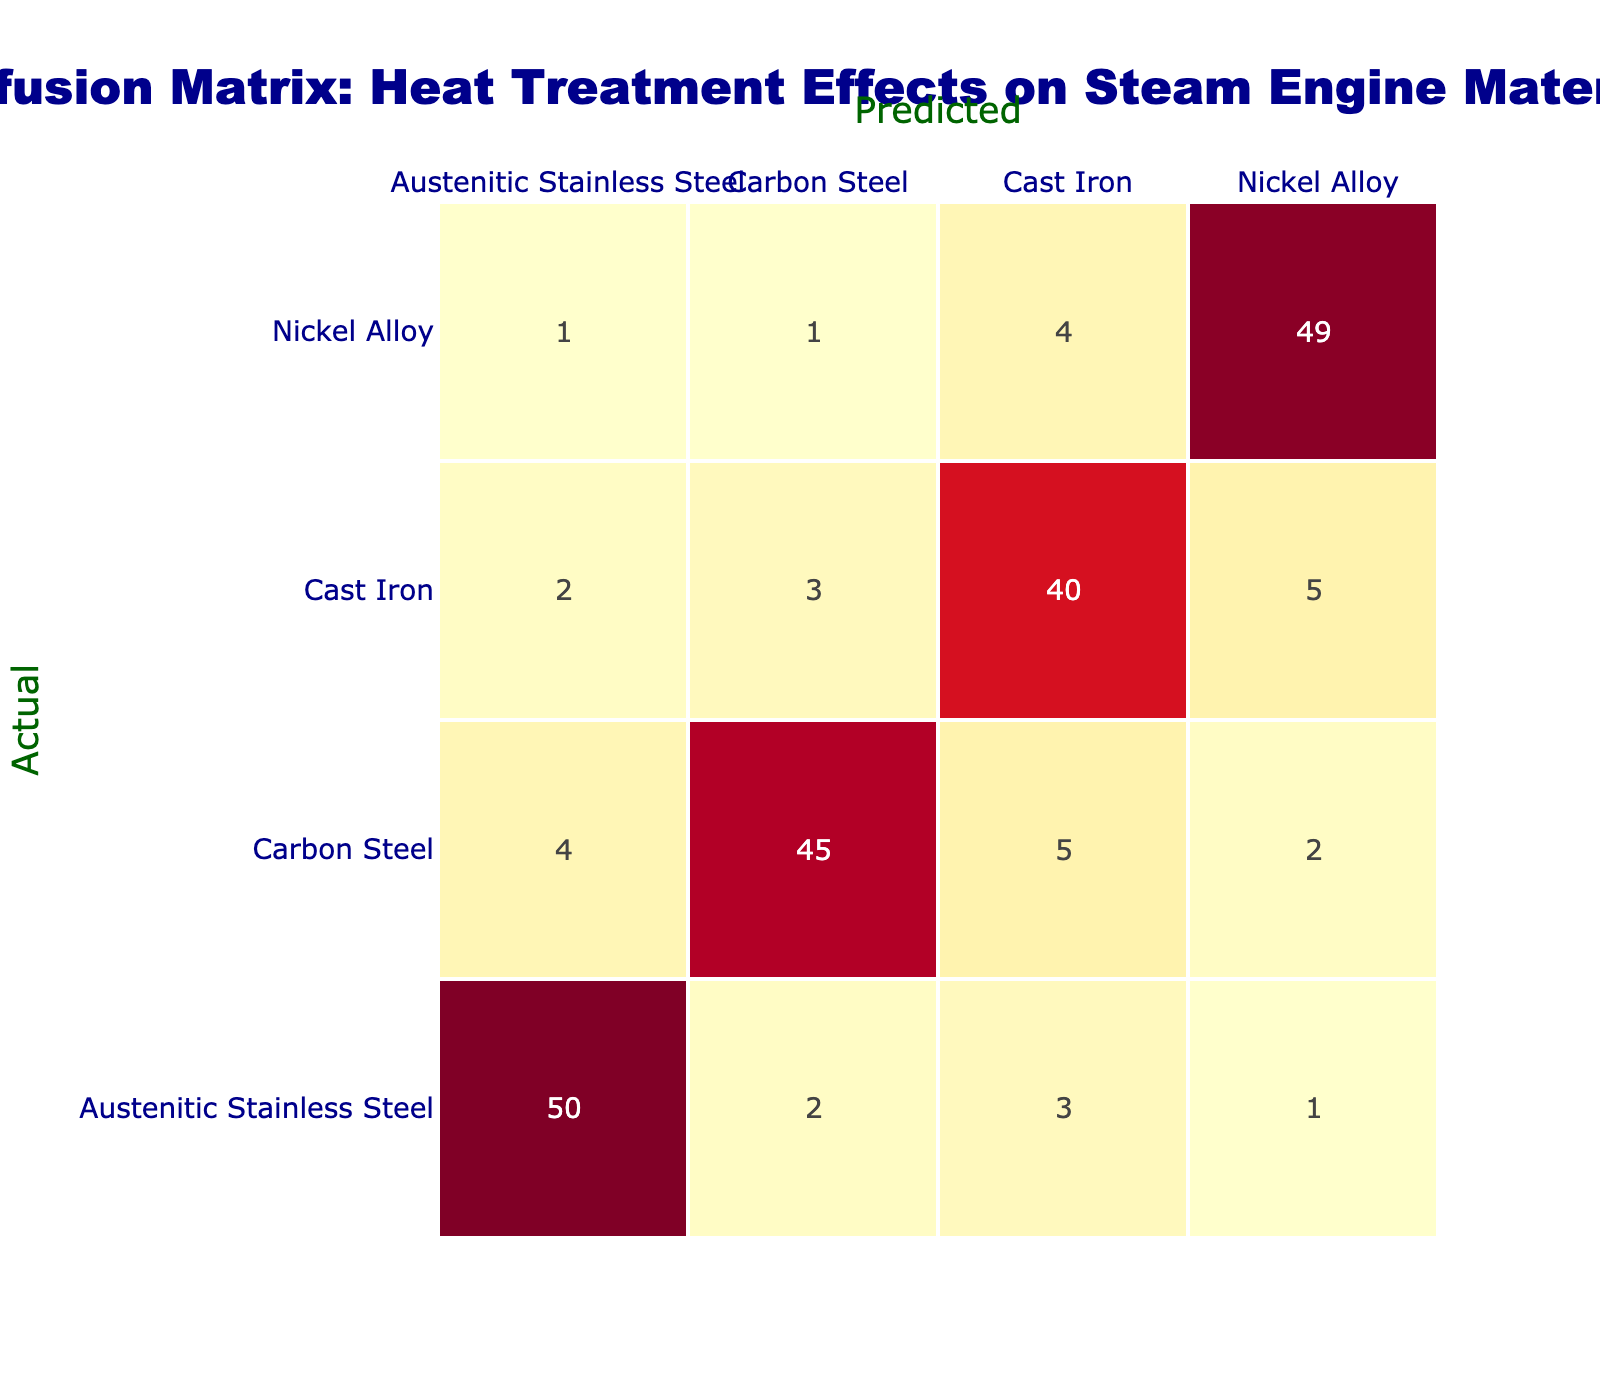What is the predicted number of Austenitic Stainless Steel components? In the table, the row for predicted Austenitic Stainless Steel shows '50', which is the value in that cell.
Answer: 50 What is the total number of errors in predicting Carbon Steel? To find the total errors for Carbon Steel, add the numbers in the Carbon Steel row that are not on the diagonal: 4 (Austenitic Stainless Steel) + 5 (Cast Iron) + 2 (Nickel Alloy) = 11.
Answer: 11 Is it true that more Nickel Alloy components were misclassified as Cast Iron than as Carbon Steel? Looking at the Nickel Alloy row, it shows 4 misclassifications as Cast Iron and 1 as Carbon Steel. Since 4 is greater than 1, the statement is true.
Answer: Yes What is the misclassification rate for Cast Iron components? The misclassification rate can be calculated by taking the total misclassifications (2 + 3 + 5 = 10) and dividing by the total actual Cast Iron (40 + 10 = 50). The rate is thus 10/50 = 0.2 or 20%.
Answer: 20% What is the average number of misclassifications across all materials? Compute the total number of misclassifications by summing all off-diagonal values (2 + 3 + 4 + 5 + 5 + 2 + 1 + 4 = 26) and dividing by the number of classes (4). Thus, the average is 26/4 = 6.5.
Answer: 6.5 Which material has the highest number of correct predictions? The highest correct predictions can be found on the diagonal, where Nickel Alloy shows '49' as the highest value compared to other materials (50, 45, 40).
Answer: Nickel Alloy How many times was Cast Iron correctly predicted? The table shows that the number of times Cast Iron components were correctly predicted is '40', which is the diagonal value in the Cast Iron row.
Answer: 40 If we combine total misclassifications for Carbon Steel and Cast Iron, how many misclassifications are there in total? The misclassifications for Carbon Steel (4 + 5 + 2 = 11) and Cast Iron (2 + 3 + 5 = 10) yield a total of 11 + 10 = 21 misclassifications combined.
Answer: 21 